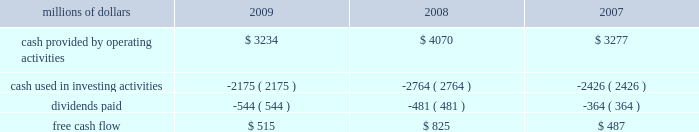2022 asset utilization 2013 in response to economic conditions and lower revenue in 2009 , we implemented productivity initiatives to improve efficiency and reduce costs , in addition to adjusting our resources to reflect lower demand .
Although varying throughout the year , our resource reductions included removing from service approximately 26% ( 26 % ) of our road locomotives and 18% ( 18 % ) of our freight car inventory by year end .
We also reduced shift levels at most rail facilities and closed or significantly reduced operations in 30 of our 114 principal rail yards .
These demand-driven resource adjustments and our productivity initiatives combined to reduce our workforce by 10% ( 10 % ) .
2022 fuel prices 2013 as the economy worsened during the third and fourth quarters of 2008 , fuel prices dropped dramatically , reaching $ 33.87 per barrel in december 2008 , a near five-year low .
Throughout 2009 , crude oil prices generally increased , ending the year around $ 80 per barrel .
Overall , our average fuel price decreased by 44% ( 44 % ) in 2009 , reducing operating expenses by $ 1.3 billion compared to 2008 .
We also reduced our consumption rate by 4% ( 4 % ) during the year , saving approximately 40 million gallons of fuel .
The use of newer , more fuel efficient locomotives ; increased use of distributed locomotive power ; fuel conservation programs ; and improved network operations and asset utilization all contributed to this improvement .
2022 free cash flow 2013 cash generated by operating activities totaled $ 3.2 billion , yielding free cash flow of $ 515 million in 2009 .
Free cash flow is defined as cash provided by operating activities , less cash used in investing activities and dividends paid .
Free cash flow is not considered a financial measure under accounting principles generally accepted in the united states ( gaap ) by sec regulation g and item 10 of sec regulation s-k .
We believe free cash flow is important in evaluating our financial performance and measures our ability to generate cash without additional external financings .
Free cash flow should be considered in addition to , rather than as a substitute for , cash provided by operating activities .
The table reconciles cash provided by operating activities ( gaap measure ) to free cash flow ( non-gaap measure ) : millions of dollars 2009 2008 2007 .
2010 outlook 2022 safety 2013 operating a safe railroad benefits our employees , our customers , our shareholders , and the public .
We will continue using a multi-faceted approach to safety , utilizing technology , risk assessment , quality control , and training , and by engaging our employees .
We will continue implementing total safety culture ( tsc ) throughout our operations .
Tsc is designed to establish , maintain , reinforce , and promote safe practices among co-workers .
This process allows us to identify and implement best practices for employee and operational safety .
Reducing grade-crossing incidents is a critical aspect of our safety programs , and we will continue our efforts to maintain , upgrade , and close crossings ; install video cameras on locomotives ; and educate the public about crossing safety through our own programs , various industry programs , and other activities .
2022 transportation plan 2013 to build upon our success in recent years , we will continue evaluating traffic flows and network logistic patterns , which can be quite dynamic from year-to-year , to identify additional opportunities to simplify operations , remove network variability and improve network efficiency and asset utilization .
We plan to adjust manpower and our locomotive and rail car fleets to .
What percent of beginning inventory of locomotives remained in service at the end of the year? 
Computations: ((1 / 1) - 26%)
Answer: 0.74. 